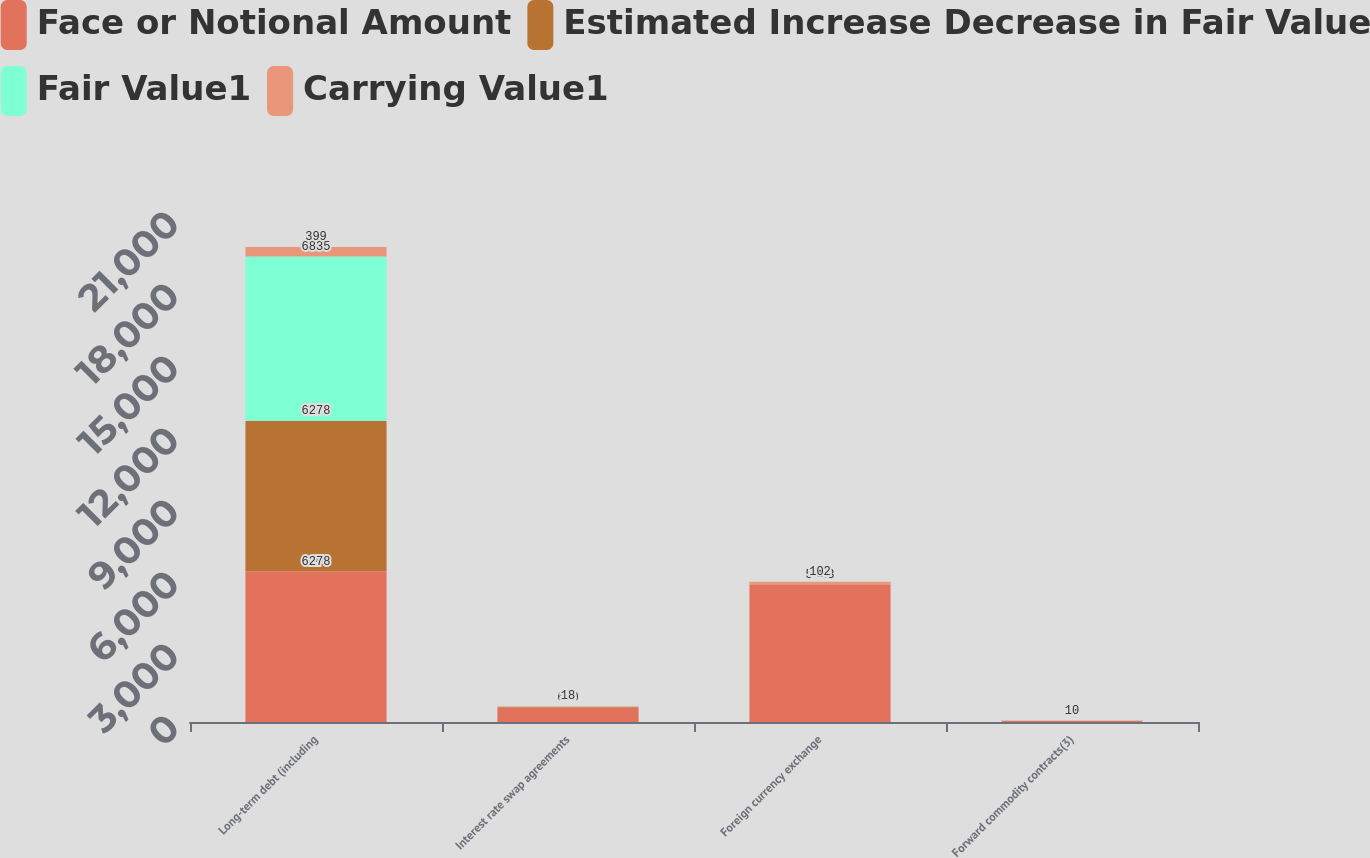Convert chart. <chart><loc_0><loc_0><loc_500><loc_500><stacked_bar_chart><ecel><fcel>Long-term debt (including<fcel>Interest rate swap agreements<fcel>Foreign currency exchange<fcel>Forward commodity contracts(3)<nl><fcel>Face or Notional Amount<fcel>6278<fcel>600<fcel>5733<fcel>52<nl><fcel>Estimated Increase Decrease in Fair Value<fcel>6278<fcel>22<fcel>2<fcel>4<nl><fcel>Fair Value1<fcel>6835<fcel>22<fcel>2<fcel>4<nl><fcel>Carrying Value1<fcel>399<fcel>18<fcel>102<fcel>10<nl></chart> 